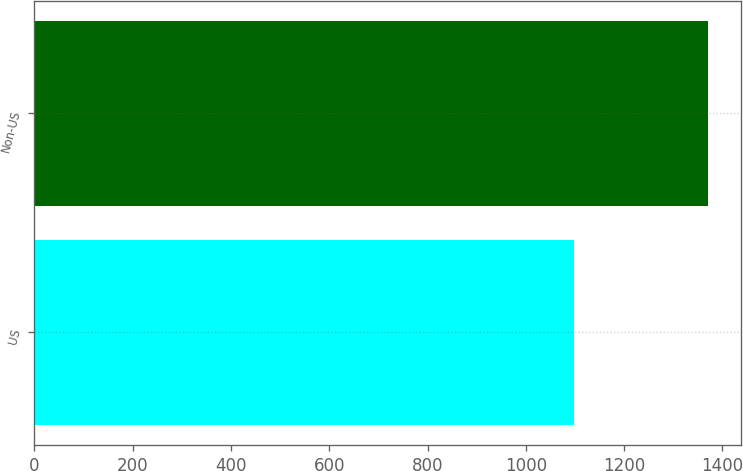Convert chart to OTSL. <chart><loc_0><loc_0><loc_500><loc_500><bar_chart><fcel>US<fcel>Non-US<nl><fcel>1098<fcel>1370<nl></chart> 